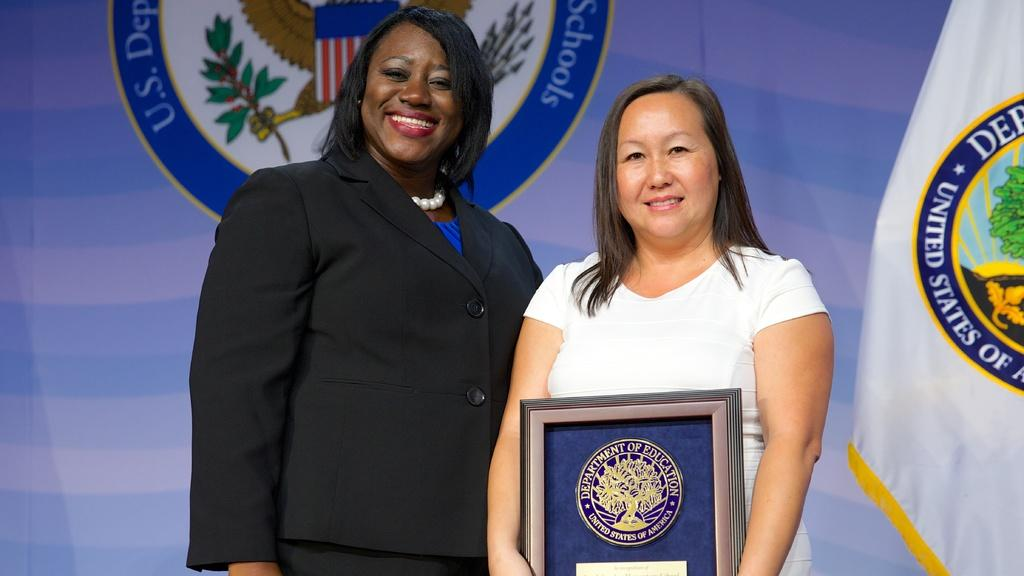<image>
Write a terse but informative summary of the picture. Two women smiling, one is holding an award from the department of education 